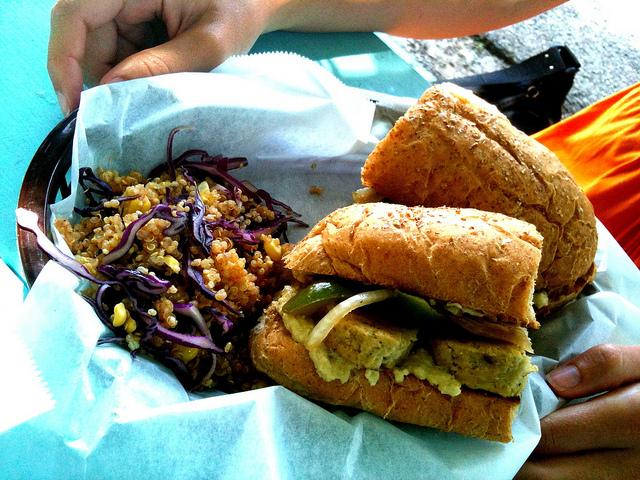What type of food is shown? sandwich 